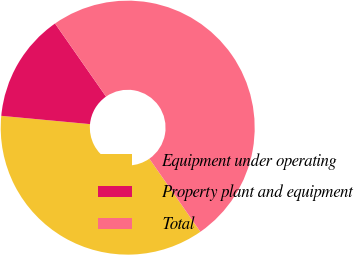Convert chart. <chart><loc_0><loc_0><loc_500><loc_500><pie_chart><fcel>Equipment under operating<fcel>Property plant and equipment<fcel>Total<nl><fcel>36.18%<fcel>13.82%<fcel>50.0%<nl></chart> 